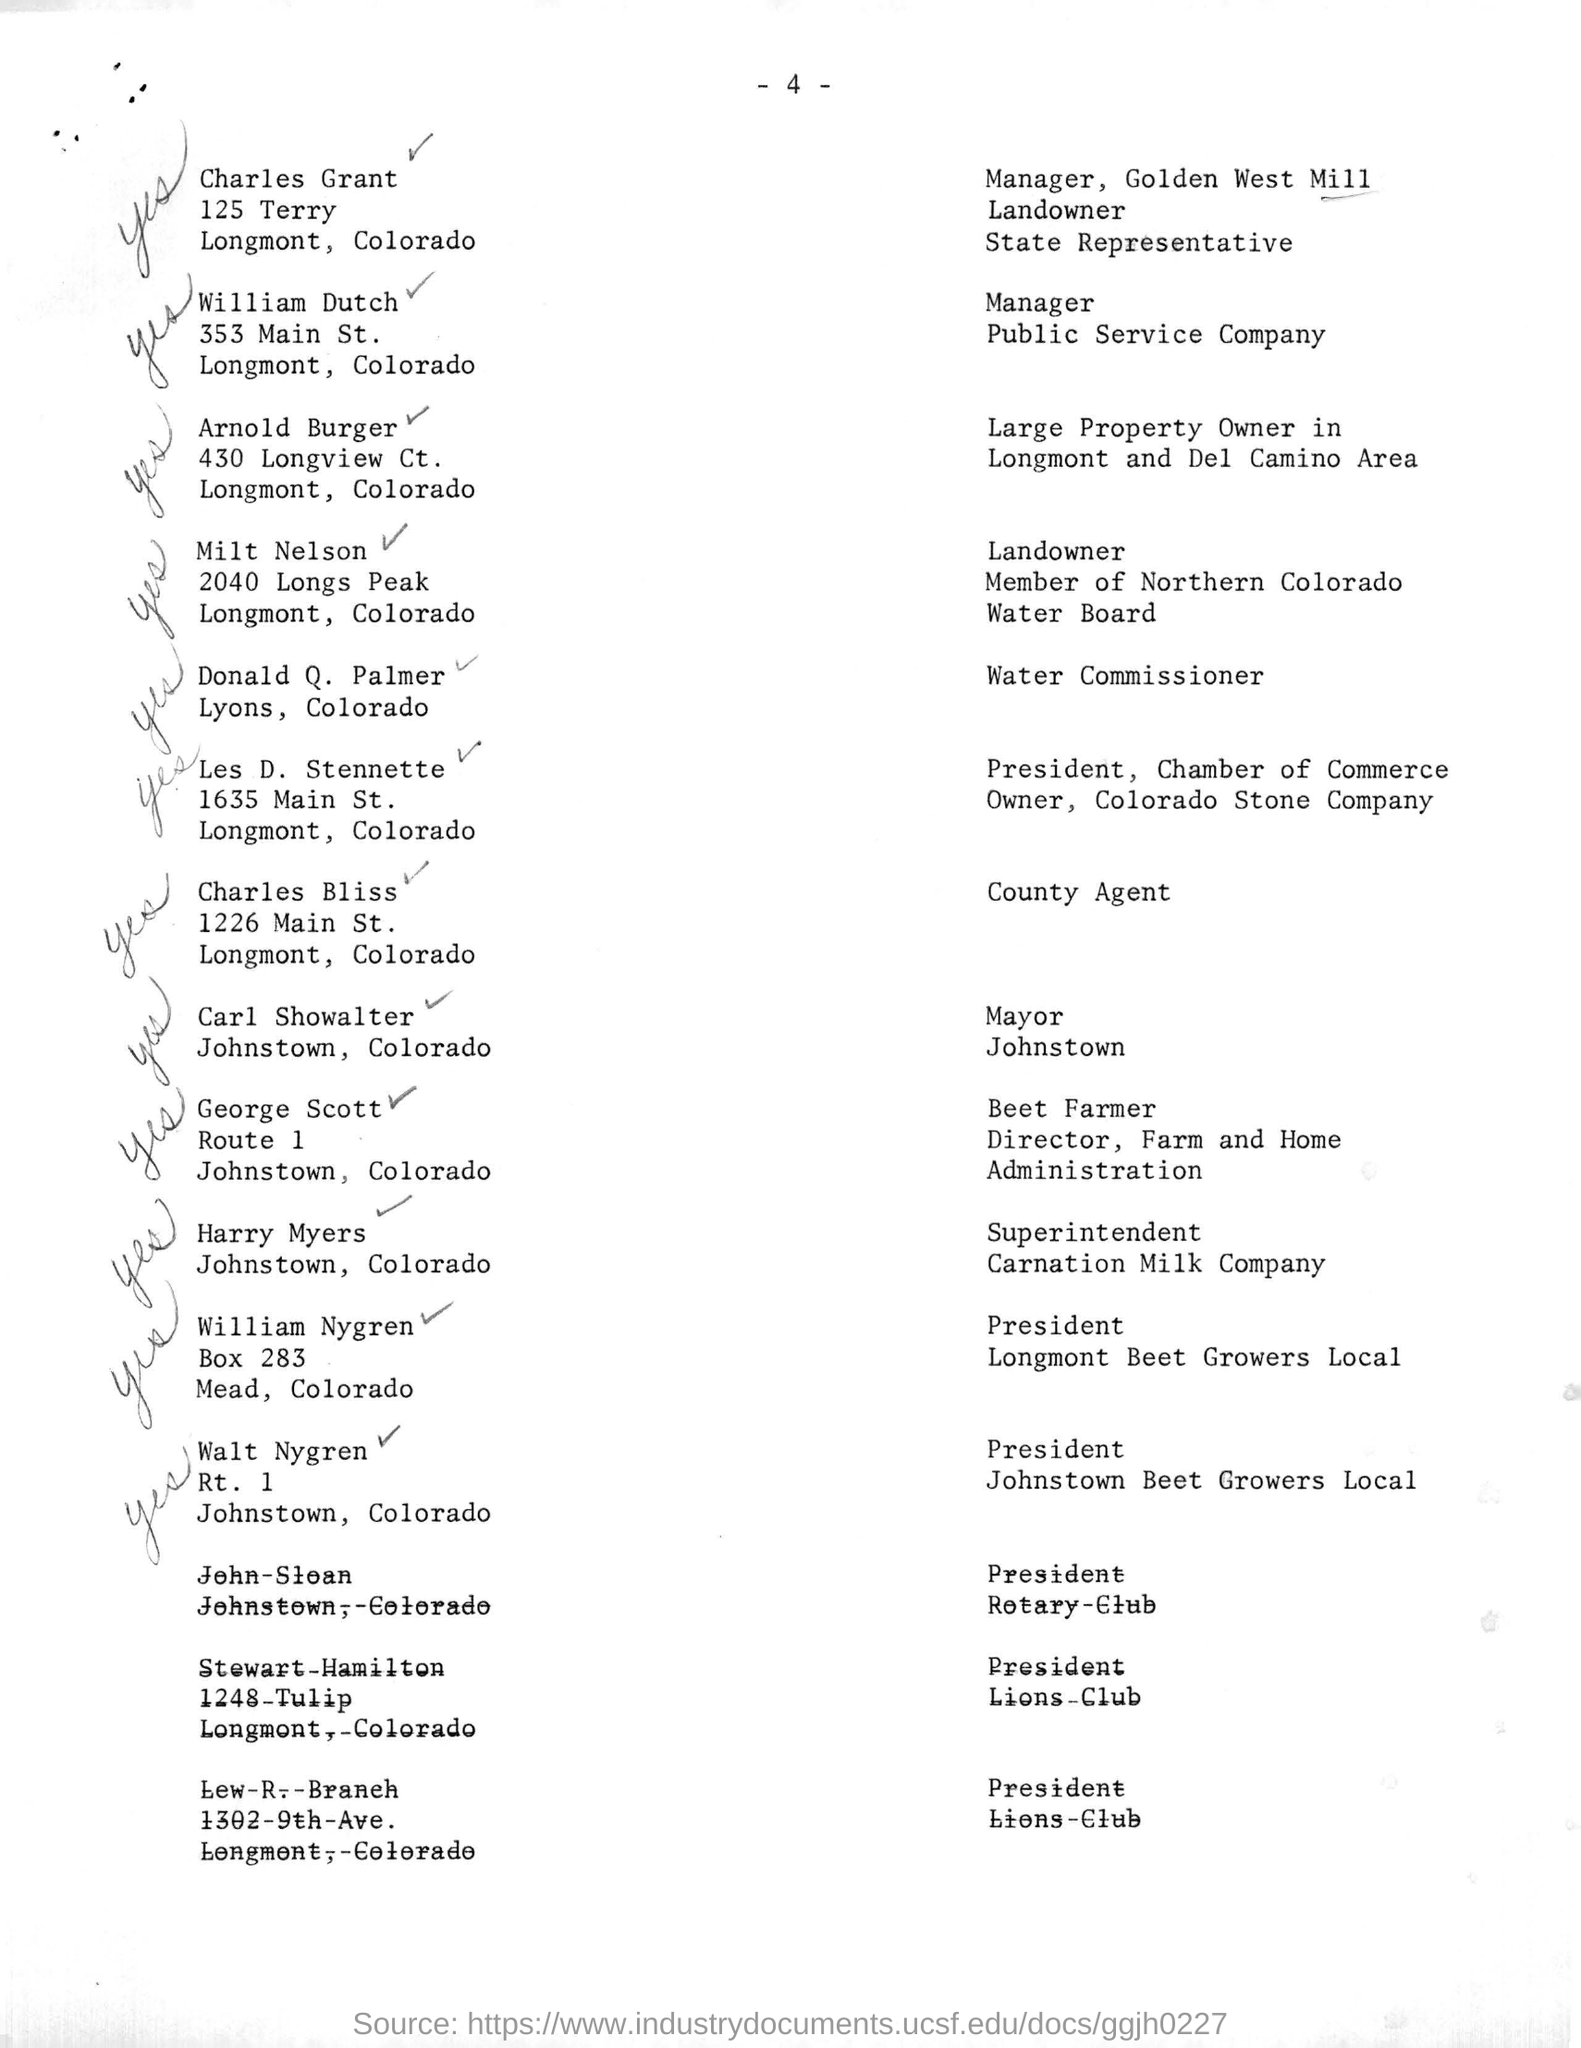Who is the manager of public service company ?
Your response must be concise. William Dutch. Who is the Country Agent ?
Provide a short and direct response. Charles Bliss. Who is the President of Longmont Beet Growers Local ?
Your response must be concise. William Nygren. 